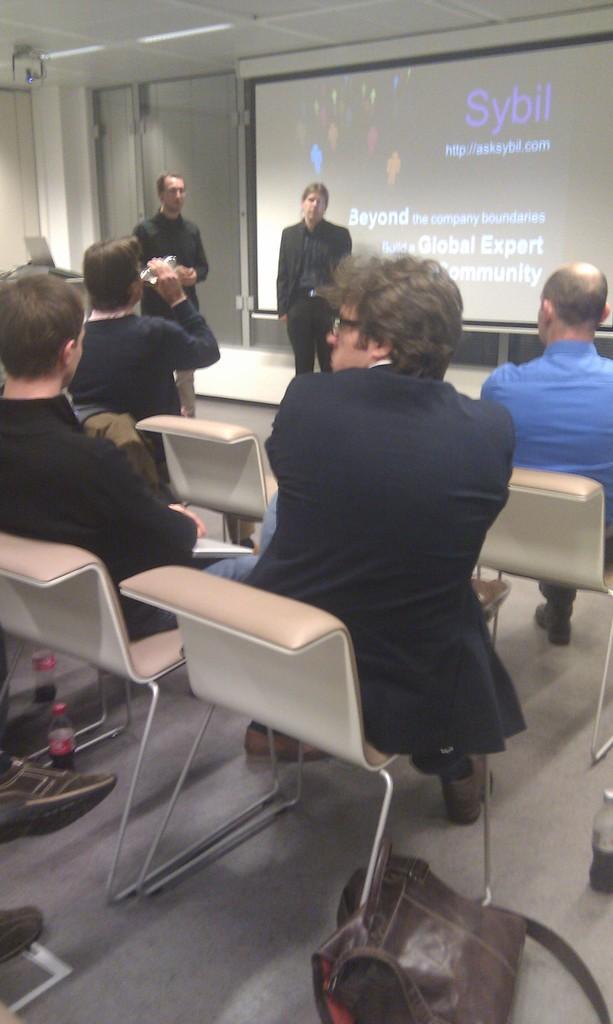Please provide a concise description of this image. There are two persons standing and there is a projected image behind them and there are group of people sitting in front of them. 